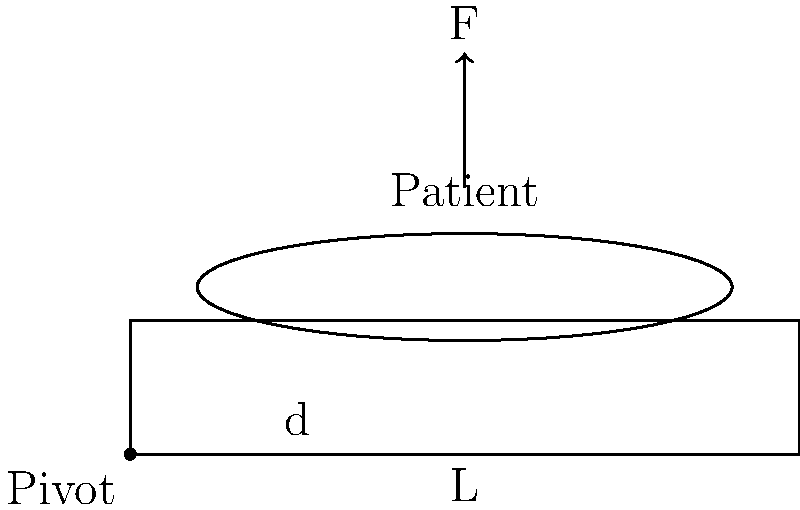A nurse needs to adjust a hospital bed with a patient on it. The bed is 2 meters long and pivots at one end. If the patient weighs 800 N and is centered on the bed, what minimum force (F) must the nurse apply at the opposite end to begin lifting the patient? Assume the weight of the bed is negligible. To solve this problem, we need to use the principle of torque and leverage. Here's a step-by-step explanation:

1) The torque equation is: $$\tau = F \times d$$
   Where $\tau$ is torque, $F$ is force, and $d$ is the perpendicular distance from the pivot point.

2) For the bed to begin lifting, the torque applied by the nurse must equal the torque created by the patient's weight.

3) The patient's weight (W) is 800 N, and they are centered on the bed. So, their distance from the pivot is half the bed's length:
   $$d_{patient} = \frac{2\text{ m}}{2} = 1\text{ m}$$

4) The torque created by the patient is:
   $$\tau_{patient} = 800\text{ N} \times 1\text{ m} = 800\text{ Nm}$$

5) The nurse applies force at the end of the bed, so their distance is the full bed length:
   $$d_{nurse} = 2\text{ m}$$

6) For equilibrium, the nurse's torque must equal the patient's torque:
   $$F_{nurse} \times 2\text{ m} = 800\text{ Nm}$$

7) Solving for $F_{nurse}$:
   $$F_{nurse} = \frac{800\text{ Nm}}{2\text{ m}} = 400\text{ N}$$

Therefore, the nurse must apply a minimum force of 400 N to begin lifting the patient.
Answer: 400 N 